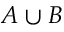<formula> <loc_0><loc_0><loc_500><loc_500>A \cup B</formula> 